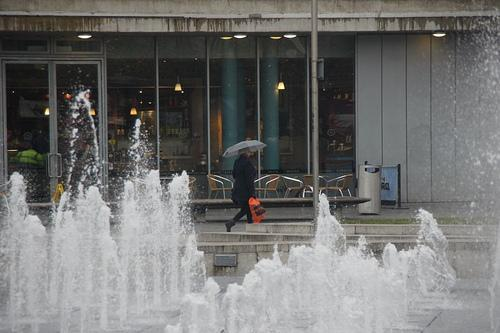Mention the type of fountain shown in the photograph. The image features an outdoor water fountain with water gushing and splashing. Can you describe the objects near the building, specifically in terms of color and material? There are brown metal chairs with silver arms and a tan-colored trash can made of silver metal. Enumerate the items held by the person in black outfit. The person in the black outfit is carrying a light grey open umbrella and a bright orange shopping bag. What is the color and style of the person's outfit, and what are they doing? The person is wearing an all-black outfit, walking with an umbrella and carrying an orange shopping bag. Identify the type of door found on the building. The door of the building is made of glass with a silver metal door handle. What is the person in the image holding in their hand? The person in the image is holding an umbrella and an orange shopping bag. Describe the windows and doors of the building. The building has large, tall glass windows and doors with a powder blue sign in the background. What type of seating arrangement is outside the building, and what color are the seats? There's a row of brown metal chairs with silver arms outside the building. Explain the elements in the image's foreground. The foreground of the image features a water fountain with tall splashes of water and a person walking and carrying a grey umbrella. What are some notable features inside the building? Inside the building, there are lamps, circle lights in the ceiling, and a store with lights. Is there a person wearing a bright pink hat in the image? There are no mentions of a person wearing a bright pink hat in the image; therefore, this instruction would confuse viewers looking for such an object. Can you find a green trash can near the chairs in the image? The trash can described in the image is silver or tan, not green; this instruction misleads the viewer into looking for a green trash can. Can you see a person riding a bicycle in the background? There is no mention of a person riding a bicycle in the information provided, which causes confusion for viewers trying to find this object in the image. Are there any small square windows in the building? The windows described in the image are large and tall made of glass, not small square windows; this would lead the viewer to search erroneously for such windows. Does the person holding the orange bag also have a blue scarf? No, it's not mentioned in the image. Is there a dog sitting near the water fountain? There is no mention of a dog in the given information, so this instruction would mislead viewers into looking for a dog near the water fountain in the image. 